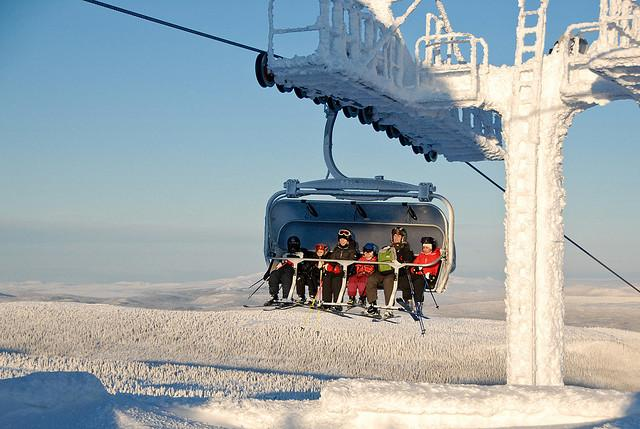Where is this group headed? Please explain your reasoning. up. The ski lift is used to take people up so they can ski down. 